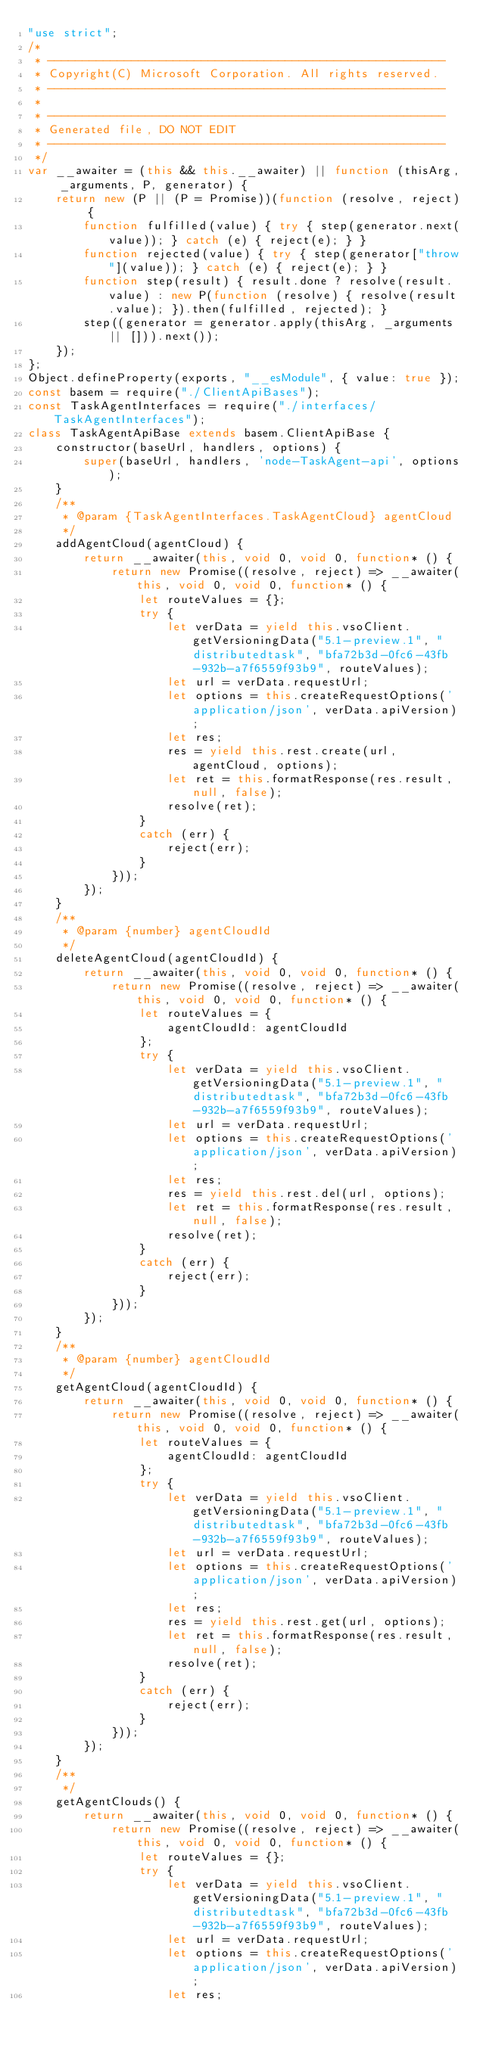<code> <loc_0><loc_0><loc_500><loc_500><_JavaScript_>"use strict";
/*
 * ---------------------------------------------------------
 * Copyright(C) Microsoft Corporation. All rights reserved.
 * ---------------------------------------------------------
 *
 * ---------------------------------------------------------
 * Generated file, DO NOT EDIT
 * ---------------------------------------------------------
 */
var __awaiter = (this && this.__awaiter) || function (thisArg, _arguments, P, generator) {
    return new (P || (P = Promise))(function (resolve, reject) {
        function fulfilled(value) { try { step(generator.next(value)); } catch (e) { reject(e); } }
        function rejected(value) { try { step(generator["throw"](value)); } catch (e) { reject(e); } }
        function step(result) { result.done ? resolve(result.value) : new P(function (resolve) { resolve(result.value); }).then(fulfilled, rejected); }
        step((generator = generator.apply(thisArg, _arguments || [])).next());
    });
};
Object.defineProperty(exports, "__esModule", { value: true });
const basem = require("./ClientApiBases");
const TaskAgentInterfaces = require("./interfaces/TaskAgentInterfaces");
class TaskAgentApiBase extends basem.ClientApiBase {
    constructor(baseUrl, handlers, options) {
        super(baseUrl, handlers, 'node-TaskAgent-api', options);
    }
    /**
     * @param {TaskAgentInterfaces.TaskAgentCloud} agentCloud
     */
    addAgentCloud(agentCloud) {
        return __awaiter(this, void 0, void 0, function* () {
            return new Promise((resolve, reject) => __awaiter(this, void 0, void 0, function* () {
                let routeValues = {};
                try {
                    let verData = yield this.vsoClient.getVersioningData("5.1-preview.1", "distributedtask", "bfa72b3d-0fc6-43fb-932b-a7f6559f93b9", routeValues);
                    let url = verData.requestUrl;
                    let options = this.createRequestOptions('application/json', verData.apiVersion);
                    let res;
                    res = yield this.rest.create(url, agentCloud, options);
                    let ret = this.formatResponse(res.result, null, false);
                    resolve(ret);
                }
                catch (err) {
                    reject(err);
                }
            }));
        });
    }
    /**
     * @param {number} agentCloudId
     */
    deleteAgentCloud(agentCloudId) {
        return __awaiter(this, void 0, void 0, function* () {
            return new Promise((resolve, reject) => __awaiter(this, void 0, void 0, function* () {
                let routeValues = {
                    agentCloudId: agentCloudId
                };
                try {
                    let verData = yield this.vsoClient.getVersioningData("5.1-preview.1", "distributedtask", "bfa72b3d-0fc6-43fb-932b-a7f6559f93b9", routeValues);
                    let url = verData.requestUrl;
                    let options = this.createRequestOptions('application/json', verData.apiVersion);
                    let res;
                    res = yield this.rest.del(url, options);
                    let ret = this.formatResponse(res.result, null, false);
                    resolve(ret);
                }
                catch (err) {
                    reject(err);
                }
            }));
        });
    }
    /**
     * @param {number} agentCloudId
     */
    getAgentCloud(agentCloudId) {
        return __awaiter(this, void 0, void 0, function* () {
            return new Promise((resolve, reject) => __awaiter(this, void 0, void 0, function* () {
                let routeValues = {
                    agentCloudId: agentCloudId
                };
                try {
                    let verData = yield this.vsoClient.getVersioningData("5.1-preview.1", "distributedtask", "bfa72b3d-0fc6-43fb-932b-a7f6559f93b9", routeValues);
                    let url = verData.requestUrl;
                    let options = this.createRequestOptions('application/json', verData.apiVersion);
                    let res;
                    res = yield this.rest.get(url, options);
                    let ret = this.formatResponse(res.result, null, false);
                    resolve(ret);
                }
                catch (err) {
                    reject(err);
                }
            }));
        });
    }
    /**
     */
    getAgentClouds() {
        return __awaiter(this, void 0, void 0, function* () {
            return new Promise((resolve, reject) => __awaiter(this, void 0, void 0, function* () {
                let routeValues = {};
                try {
                    let verData = yield this.vsoClient.getVersioningData("5.1-preview.1", "distributedtask", "bfa72b3d-0fc6-43fb-932b-a7f6559f93b9", routeValues);
                    let url = verData.requestUrl;
                    let options = this.createRequestOptions('application/json', verData.apiVersion);
                    let res;</code> 